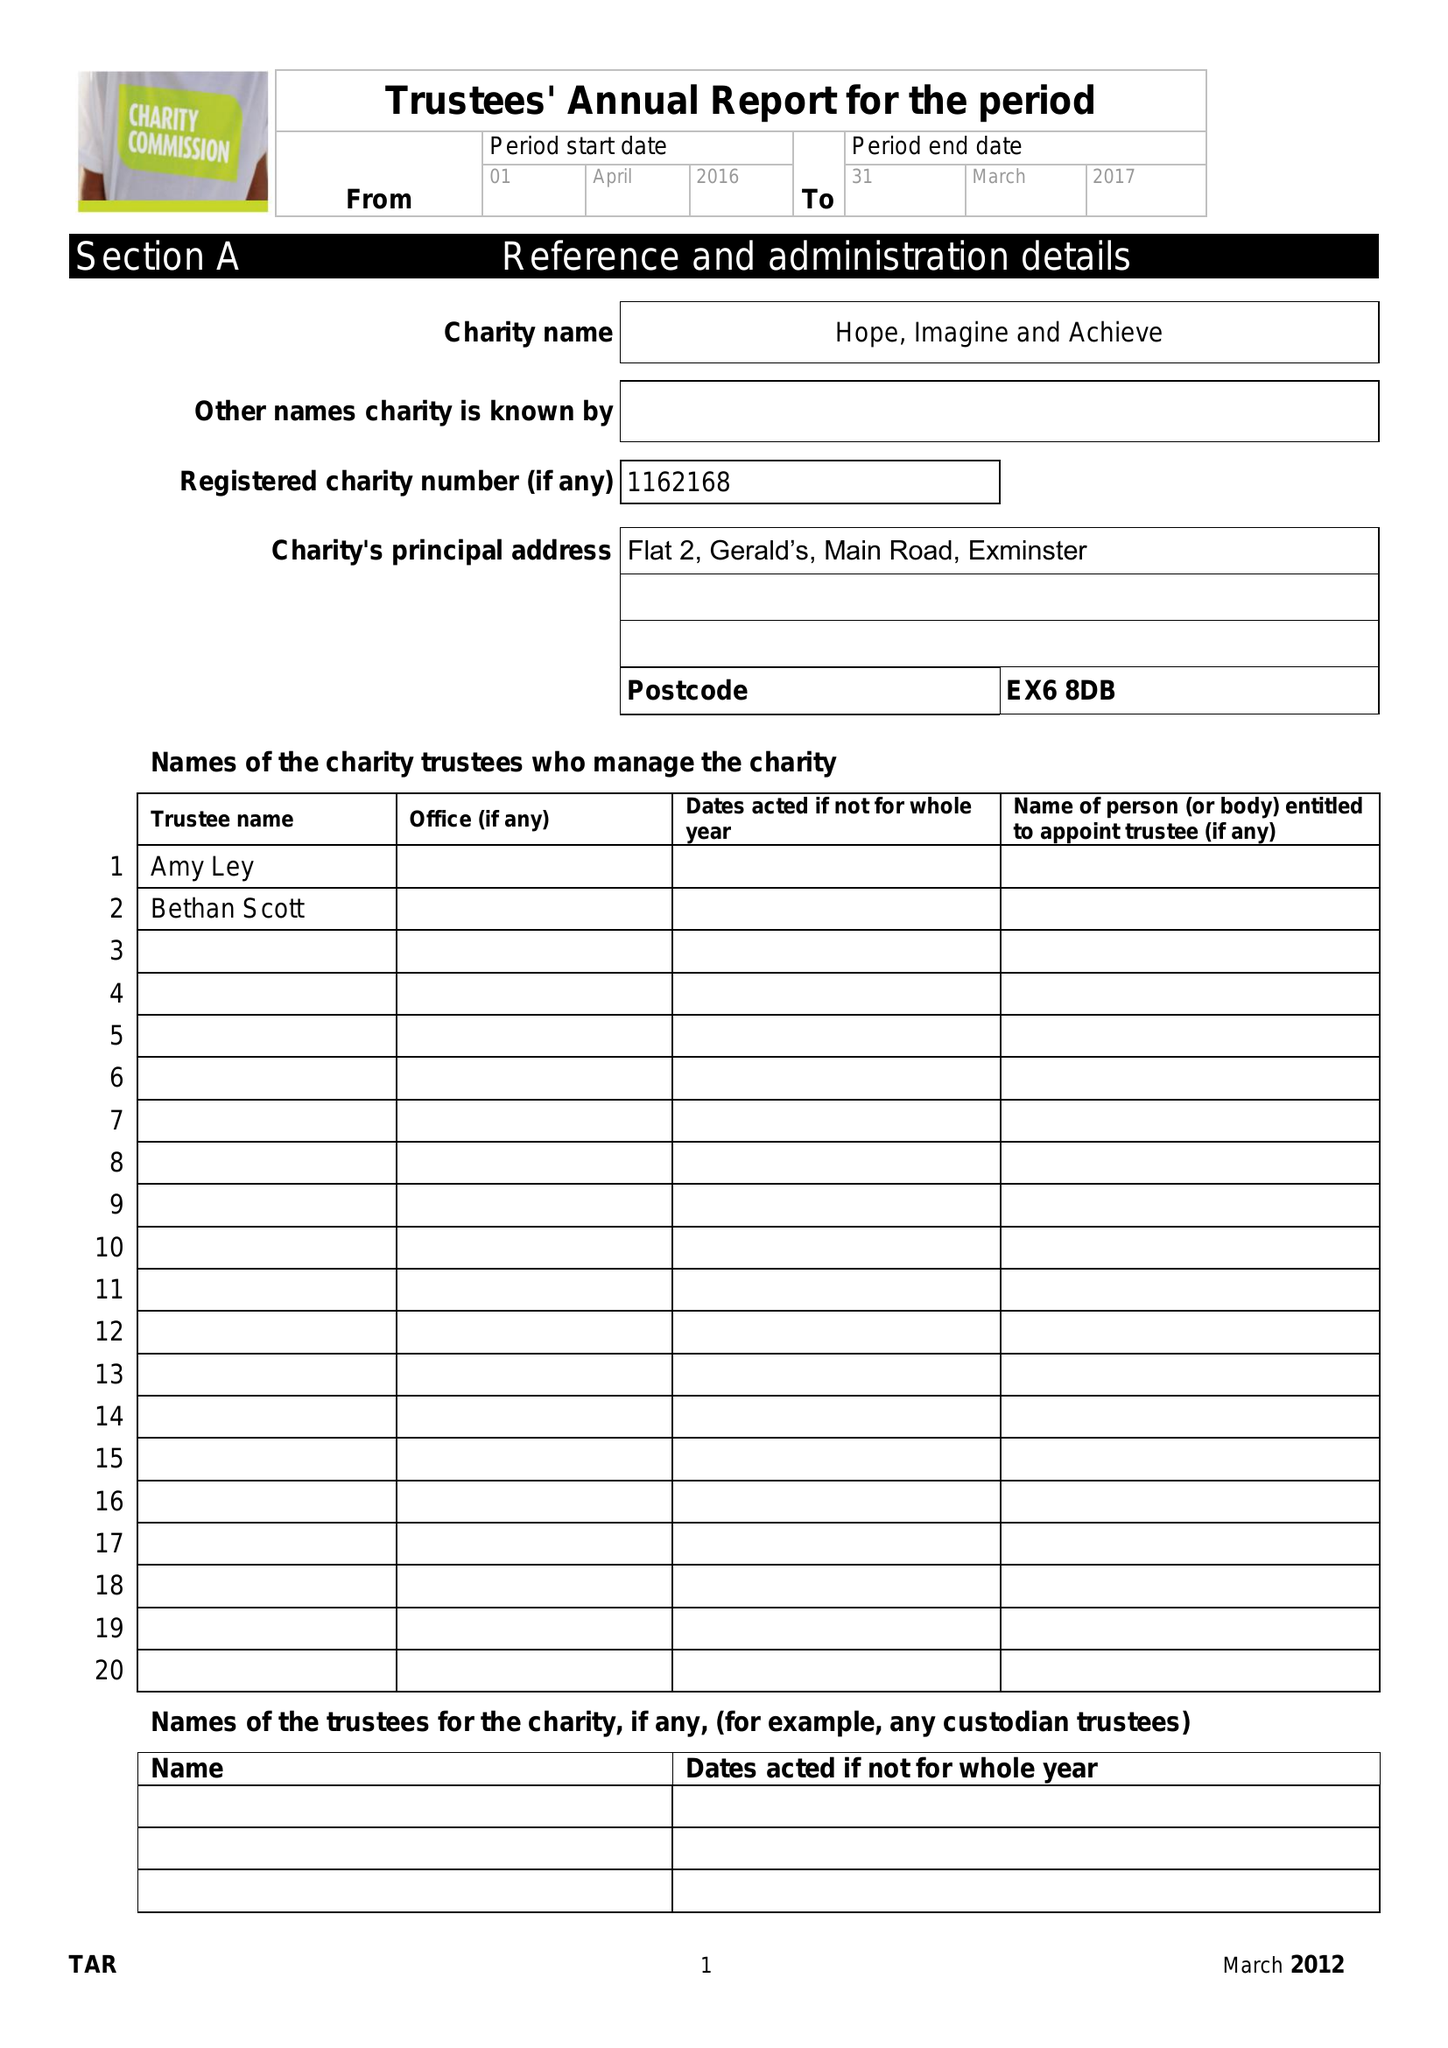What is the value for the charity_name?
Answer the question using a single word or phrase. Hope, Imagine and Achieve 